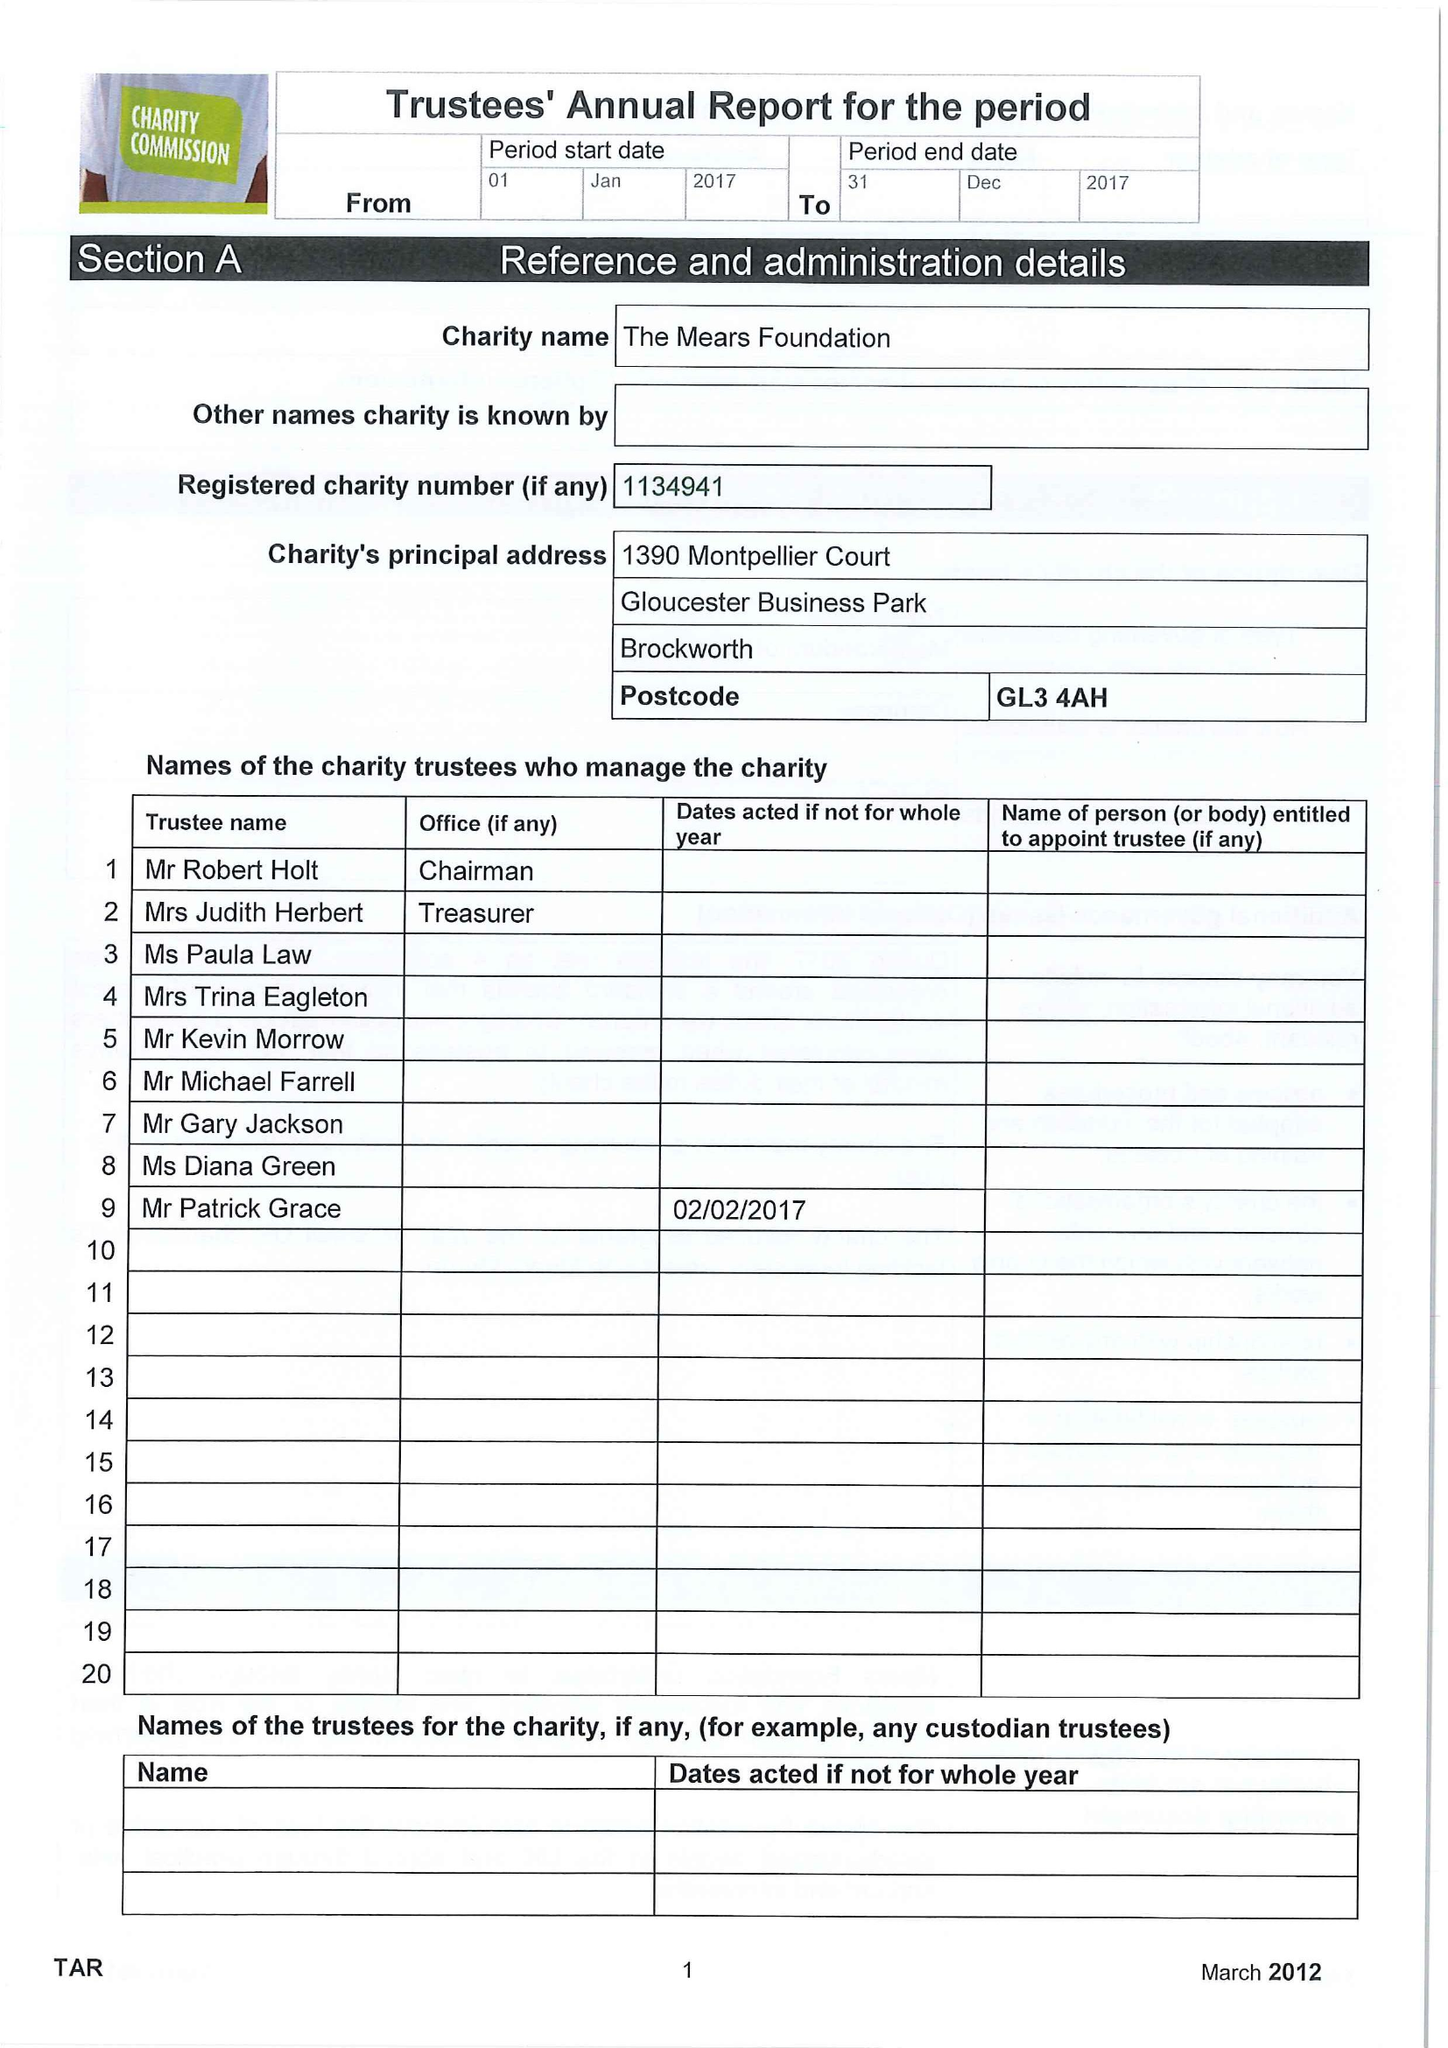What is the value for the address__post_town?
Answer the question using a single word or phrase. GLOUCESTER 